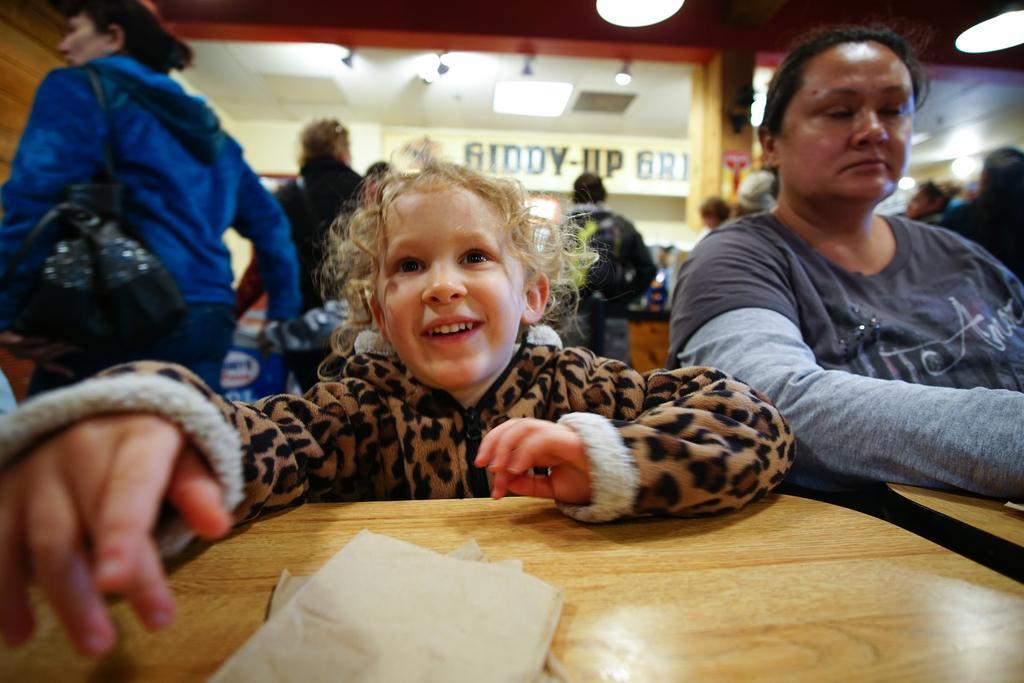In one or two sentences, can you explain what this image depicts? In this image there are tables truncated towards the bottom of the image, there are papers on the table, there are two persons sitting, there is a person wearing a bag, there are persons standing, there is text on the glass, there are lights, there is a roof, there are lights truncated towards the top of the image, there is wall truncated towards the right of the image, there are persons truncated towards the right of the image, there is a wooden wall truncated towards the left of the image. 